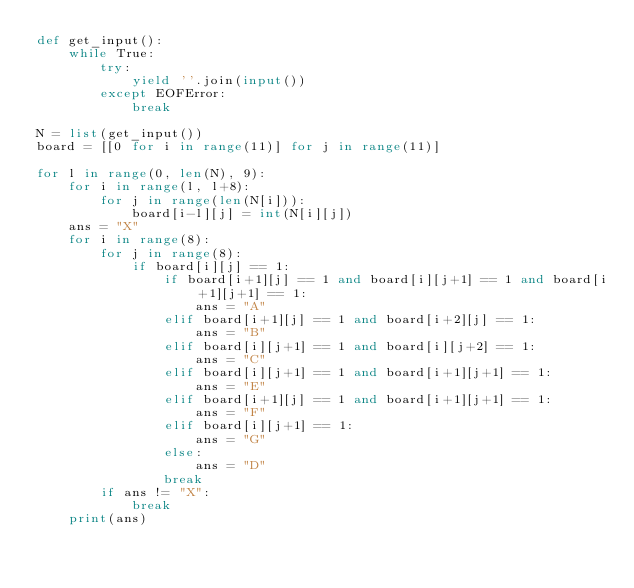<code> <loc_0><loc_0><loc_500><loc_500><_Python_>def get_input():
    while True:
        try:
            yield ''.join(input())
        except EOFError:
            break

N = list(get_input())
board = [[0 for i in range(11)] for j in range(11)]

for l in range(0, len(N), 9):
    for i in range(l, l+8):
        for j in range(len(N[i])):
            board[i-l][j] = int(N[i][j])
    ans = "X"
    for i in range(8):
        for j in range(8):
            if board[i][j] == 1:
                if board[i+1][j] == 1 and board[i][j+1] == 1 and board[i+1][j+1] == 1:
                    ans = "A"
                elif board[i+1][j] == 1 and board[i+2][j] == 1:
                    ans = "B"
                elif board[i][j+1] == 1 and board[i][j+2] == 1:
                    ans = "C"
                elif board[i][j+1] == 1 and board[i+1][j+1] == 1:
                    ans = "E"
                elif board[i+1][j] == 1 and board[i+1][j+1] == 1:
                    ans = "F"
                elif board[i][j+1] == 1:
                    ans = "G"
                else:
                    ans = "D"
                break
        if ans != "X":
            break
    print(ans)
</code> 